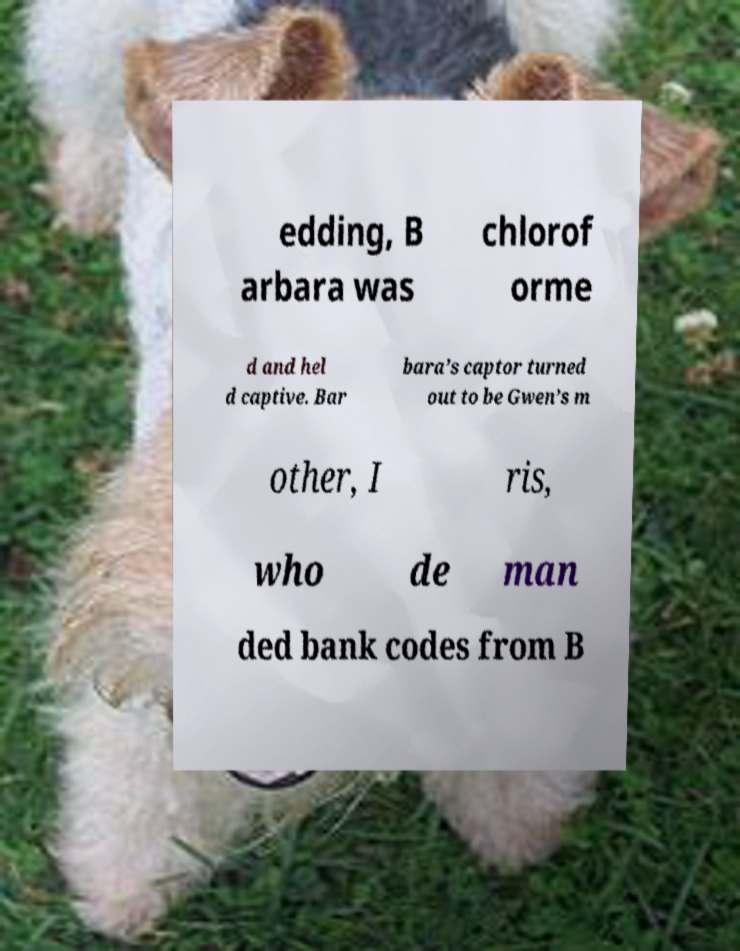I need the written content from this picture converted into text. Can you do that? edding, B arbara was chlorof orme d and hel d captive. Bar bara’s captor turned out to be Gwen’s m other, I ris, who de man ded bank codes from B 